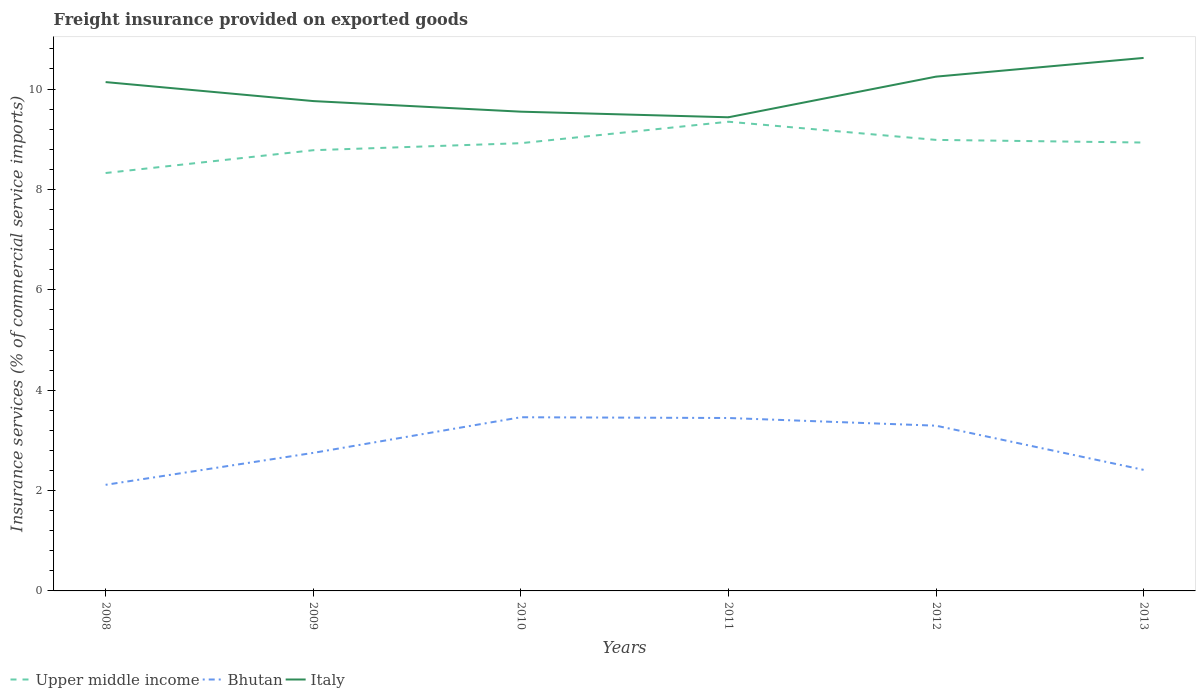How many different coloured lines are there?
Your response must be concise. 3. Is the number of lines equal to the number of legend labels?
Ensure brevity in your answer.  Yes. Across all years, what is the maximum freight insurance provided on exported goods in Italy?
Give a very brief answer. 9.44. In which year was the freight insurance provided on exported goods in Upper middle income maximum?
Give a very brief answer. 2008. What is the total freight insurance provided on exported goods in Bhutan in the graph?
Make the answer very short. 0.02. What is the difference between the highest and the second highest freight insurance provided on exported goods in Bhutan?
Keep it short and to the point. 1.35. What is the difference between the highest and the lowest freight insurance provided on exported goods in Upper middle income?
Keep it short and to the point. 4. How many lines are there?
Your answer should be compact. 3. Does the graph contain any zero values?
Your answer should be compact. No. Where does the legend appear in the graph?
Offer a terse response. Bottom left. What is the title of the graph?
Provide a succinct answer. Freight insurance provided on exported goods. What is the label or title of the Y-axis?
Offer a terse response. Insurance services (% of commercial service imports). What is the Insurance services (% of commercial service imports) in Upper middle income in 2008?
Provide a short and direct response. 8.33. What is the Insurance services (% of commercial service imports) in Bhutan in 2008?
Give a very brief answer. 2.11. What is the Insurance services (% of commercial service imports) in Italy in 2008?
Offer a terse response. 10.14. What is the Insurance services (% of commercial service imports) of Upper middle income in 2009?
Offer a very short reply. 8.78. What is the Insurance services (% of commercial service imports) of Bhutan in 2009?
Give a very brief answer. 2.75. What is the Insurance services (% of commercial service imports) of Italy in 2009?
Your answer should be compact. 9.76. What is the Insurance services (% of commercial service imports) in Upper middle income in 2010?
Offer a terse response. 8.92. What is the Insurance services (% of commercial service imports) of Bhutan in 2010?
Your response must be concise. 3.46. What is the Insurance services (% of commercial service imports) of Italy in 2010?
Your answer should be compact. 9.55. What is the Insurance services (% of commercial service imports) in Upper middle income in 2011?
Ensure brevity in your answer.  9.35. What is the Insurance services (% of commercial service imports) of Bhutan in 2011?
Your response must be concise. 3.45. What is the Insurance services (% of commercial service imports) of Italy in 2011?
Make the answer very short. 9.44. What is the Insurance services (% of commercial service imports) of Upper middle income in 2012?
Provide a short and direct response. 8.99. What is the Insurance services (% of commercial service imports) in Bhutan in 2012?
Ensure brevity in your answer.  3.29. What is the Insurance services (% of commercial service imports) of Italy in 2012?
Make the answer very short. 10.25. What is the Insurance services (% of commercial service imports) of Upper middle income in 2013?
Your answer should be very brief. 8.93. What is the Insurance services (% of commercial service imports) of Bhutan in 2013?
Your answer should be very brief. 2.41. What is the Insurance services (% of commercial service imports) of Italy in 2013?
Provide a short and direct response. 10.62. Across all years, what is the maximum Insurance services (% of commercial service imports) of Upper middle income?
Provide a short and direct response. 9.35. Across all years, what is the maximum Insurance services (% of commercial service imports) of Bhutan?
Give a very brief answer. 3.46. Across all years, what is the maximum Insurance services (% of commercial service imports) of Italy?
Provide a succinct answer. 10.62. Across all years, what is the minimum Insurance services (% of commercial service imports) in Upper middle income?
Offer a very short reply. 8.33. Across all years, what is the minimum Insurance services (% of commercial service imports) in Bhutan?
Make the answer very short. 2.11. Across all years, what is the minimum Insurance services (% of commercial service imports) of Italy?
Offer a terse response. 9.44. What is the total Insurance services (% of commercial service imports) in Upper middle income in the graph?
Ensure brevity in your answer.  53.3. What is the total Insurance services (% of commercial service imports) of Bhutan in the graph?
Keep it short and to the point. 17.47. What is the total Insurance services (% of commercial service imports) in Italy in the graph?
Your answer should be compact. 59.75. What is the difference between the Insurance services (% of commercial service imports) in Upper middle income in 2008 and that in 2009?
Give a very brief answer. -0.45. What is the difference between the Insurance services (% of commercial service imports) in Bhutan in 2008 and that in 2009?
Make the answer very short. -0.64. What is the difference between the Insurance services (% of commercial service imports) in Italy in 2008 and that in 2009?
Offer a terse response. 0.38. What is the difference between the Insurance services (% of commercial service imports) of Upper middle income in 2008 and that in 2010?
Offer a terse response. -0.59. What is the difference between the Insurance services (% of commercial service imports) of Bhutan in 2008 and that in 2010?
Give a very brief answer. -1.35. What is the difference between the Insurance services (% of commercial service imports) of Italy in 2008 and that in 2010?
Provide a succinct answer. 0.59. What is the difference between the Insurance services (% of commercial service imports) of Upper middle income in 2008 and that in 2011?
Your response must be concise. -1.02. What is the difference between the Insurance services (% of commercial service imports) of Bhutan in 2008 and that in 2011?
Your answer should be very brief. -1.33. What is the difference between the Insurance services (% of commercial service imports) of Italy in 2008 and that in 2011?
Offer a very short reply. 0.7. What is the difference between the Insurance services (% of commercial service imports) of Upper middle income in 2008 and that in 2012?
Make the answer very short. -0.66. What is the difference between the Insurance services (% of commercial service imports) of Bhutan in 2008 and that in 2012?
Your answer should be very brief. -1.18. What is the difference between the Insurance services (% of commercial service imports) of Italy in 2008 and that in 2012?
Keep it short and to the point. -0.11. What is the difference between the Insurance services (% of commercial service imports) in Upper middle income in 2008 and that in 2013?
Ensure brevity in your answer.  -0.61. What is the difference between the Insurance services (% of commercial service imports) of Bhutan in 2008 and that in 2013?
Make the answer very short. -0.3. What is the difference between the Insurance services (% of commercial service imports) in Italy in 2008 and that in 2013?
Give a very brief answer. -0.48. What is the difference between the Insurance services (% of commercial service imports) in Upper middle income in 2009 and that in 2010?
Give a very brief answer. -0.14. What is the difference between the Insurance services (% of commercial service imports) of Bhutan in 2009 and that in 2010?
Offer a terse response. -0.71. What is the difference between the Insurance services (% of commercial service imports) of Italy in 2009 and that in 2010?
Provide a succinct answer. 0.21. What is the difference between the Insurance services (% of commercial service imports) in Upper middle income in 2009 and that in 2011?
Your answer should be very brief. -0.57. What is the difference between the Insurance services (% of commercial service imports) in Bhutan in 2009 and that in 2011?
Provide a short and direct response. -0.7. What is the difference between the Insurance services (% of commercial service imports) of Italy in 2009 and that in 2011?
Provide a succinct answer. 0.32. What is the difference between the Insurance services (% of commercial service imports) in Upper middle income in 2009 and that in 2012?
Give a very brief answer. -0.21. What is the difference between the Insurance services (% of commercial service imports) of Bhutan in 2009 and that in 2012?
Give a very brief answer. -0.54. What is the difference between the Insurance services (% of commercial service imports) in Italy in 2009 and that in 2012?
Keep it short and to the point. -0.49. What is the difference between the Insurance services (% of commercial service imports) of Upper middle income in 2009 and that in 2013?
Offer a terse response. -0.15. What is the difference between the Insurance services (% of commercial service imports) in Bhutan in 2009 and that in 2013?
Your answer should be very brief. 0.34. What is the difference between the Insurance services (% of commercial service imports) in Italy in 2009 and that in 2013?
Provide a succinct answer. -0.86. What is the difference between the Insurance services (% of commercial service imports) in Upper middle income in 2010 and that in 2011?
Give a very brief answer. -0.43. What is the difference between the Insurance services (% of commercial service imports) in Bhutan in 2010 and that in 2011?
Your answer should be compact. 0.02. What is the difference between the Insurance services (% of commercial service imports) in Italy in 2010 and that in 2011?
Provide a short and direct response. 0.11. What is the difference between the Insurance services (% of commercial service imports) in Upper middle income in 2010 and that in 2012?
Ensure brevity in your answer.  -0.07. What is the difference between the Insurance services (% of commercial service imports) of Bhutan in 2010 and that in 2012?
Keep it short and to the point. 0.17. What is the difference between the Insurance services (% of commercial service imports) in Italy in 2010 and that in 2012?
Give a very brief answer. -0.7. What is the difference between the Insurance services (% of commercial service imports) of Upper middle income in 2010 and that in 2013?
Offer a very short reply. -0.01. What is the difference between the Insurance services (% of commercial service imports) in Bhutan in 2010 and that in 2013?
Offer a very short reply. 1.05. What is the difference between the Insurance services (% of commercial service imports) in Italy in 2010 and that in 2013?
Your answer should be very brief. -1.07. What is the difference between the Insurance services (% of commercial service imports) of Upper middle income in 2011 and that in 2012?
Offer a very short reply. 0.36. What is the difference between the Insurance services (% of commercial service imports) of Bhutan in 2011 and that in 2012?
Your answer should be compact. 0.15. What is the difference between the Insurance services (% of commercial service imports) of Italy in 2011 and that in 2012?
Offer a terse response. -0.81. What is the difference between the Insurance services (% of commercial service imports) in Upper middle income in 2011 and that in 2013?
Your answer should be compact. 0.41. What is the difference between the Insurance services (% of commercial service imports) in Bhutan in 2011 and that in 2013?
Your answer should be very brief. 1.03. What is the difference between the Insurance services (% of commercial service imports) in Italy in 2011 and that in 2013?
Give a very brief answer. -1.18. What is the difference between the Insurance services (% of commercial service imports) of Upper middle income in 2012 and that in 2013?
Make the answer very short. 0.05. What is the difference between the Insurance services (% of commercial service imports) of Bhutan in 2012 and that in 2013?
Your answer should be very brief. 0.88. What is the difference between the Insurance services (% of commercial service imports) of Italy in 2012 and that in 2013?
Provide a short and direct response. -0.37. What is the difference between the Insurance services (% of commercial service imports) of Upper middle income in 2008 and the Insurance services (% of commercial service imports) of Bhutan in 2009?
Provide a short and direct response. 5.58. What is the difference between the Insurance services (% of commercial service imports) of Upper middle income in 2008 and the Insurance services (% of commercial service imports) of Italy in 2009?
Give a very brief answer. -1.43. What is the difference between the Insurance services (% of commercial service imports) in Bhutan in 2008 and the Insurance services (% of commercial service imports) in Italy in 2009?
Ensure brevity in your answer.  -7.65. What is the difference between the Insurance services (% of commercial service imports) in Upper middle income in 2008 and the Insurance services (% of commercial service imports) in Bhutan in 2010?
Your answer should be very brief. 4.87. What is the difference between the Insurance services (% of commercial service imports) in Upper middle income in 2008 and the Insurance services (% of commercial service imports) in Italy in 2010?
Provide a short and direct response. -1.22. What is the difference between the Insurance services (% of commercial service imports) of Bhutan in 2008 and the Insurance services (% of commercial service imports) of Italy in 2010?
Give a very brief answer. -7.43. What is the difference between the Insurance services (% of commercial service imports) in Upper middle income in 2008 and the Insurance services (% of commercial service imports) in Bhutan in 2011?
Your response must be concise. 4.88. What is the difference between the Insurance services (% of commercial service imports) of Upper middle income in 2008 and the Insurance services (% of commercial service imports) of Italy in 2011?
Your answer should be very brief. -1.11. What is the difference between the Insurance services (% of commercial service imports) in Bhutan in 2008 and the Insurance services (% of commercial service imports) in Italy in 2011?
Make the answer very short. -7.32. What is the difference between the Insurance services (% of commercial service imports) of Upper middle income in 2008 and the Insurance services (% of commercial service imports) of Bhutan in 2012?
Keep it short and to the point. 5.03. What is the difference between the Insurance services (% of commercial service imports) of Upper middle income in 2008 and the Insurance services (% of commercial service imports) of Italy in 2012?
Your answer should be very brief. -1.92. What is the difference between the Insurance services (% of commercial service imports) of Bhutan in 2008 and the Insurance services (% of commercial service imports) of Italy in 2012?
Your response must be concise. -8.13. What is the difference between the Insurance services (% of commercial service imports) in Upper middle income in 2008 and the Insurance services (% of commercial service imports) in Bhutan in 2013?
Provide a succinct answer. 5.91. What is the difference between the Insurance services (% of commercial service imports) in Upper middle income in 2008 and the Insurance services (% of commercial service imports) in Italy in 2013?
Provide a succinct answer. -2.29. What is the difference between the Insurance services (% of commercial service imports) in Bhutan in 2008 and the Insurance services (% of commercial service imports) in Italy in 2013?
Provide a short and direct response. -8.51. What is the difference between the Insurance services (% of commercial service imports) of Upper middle income in 2009 and the Insurance services (% of commercial service imports) of Bhutan in 2010?
Offer a terse response. 5.32. What is the difference between the Insurance services (% of commercial service imports) of Upper middle income in 2009 and the Insurance services (% of commercial service imports) of Italy in 2010?
Your answer should be very brief. -0.77. What is the difference between the Insurance services (% of commercial service imports) of Bhutan in 2009 and the Insurance services (% of commercial service imports) of Italy in 2010?
Provide a short and direct response. -6.8. What is the difference between the Insurance services (% of commercial service imports) in Upper middle income in 2009 and the Insurance services (% of commercial service imports) in Bhutan in 2011?
Give a very brief answer. 5.34. What is the difference between the Insurance services (% of commercial service imports) of Upper middle income in 2009 and the Insurance services (% of commercial service imports) of Italy in 2011?
Your answer should be very brief. -0.66. What is the difference between the Insurance services (% of commercial service imports) in Bhutan in 2009 and the Insurance services (% of commercial service imports) in Italy in 2011?
Your answer should be very brief. -6.69. What is the difference between the Insurance services (% of commercial service imports) of Upper middle income in 2009 and the Insurance services (% of commercial service imports) of Bhutan in 2012?
Ensure brevity in your answer.  5.49. What is the difference between the Insurance services (% of commercial service imports) in Upper middle income in 2009 and the Insurance services (% of commercial service imports) in Italy in 2012?
Provide a succinct answer. -1.47. What is the difference between the Insurance services (% of commercial service imports) of Bhutan in 2009 and the Insurance services (% of commercial service imports) of Italy in 2012?
Give a very brief answer. -7.5. What is the difference between the Insurance services (% of commercial service imports) of Upper middle income in 2009 and the Insurance services (% of commercial service imports) of Bhutan in 2013?
Your answer should be compact. 6.37. What is the difference between the Insurance services (% of commercial service imports) in Upper middle income in 2009 and the Insurance services (% of commercial service imports) in Italy in 2013?
Give a very brief answer. -1.84. What is the difference between the Insurance services (% of commercial service imports) in Bhutan in 2009 and the Insurance services (% of commercial service imports) in Italy in 2013?
Ensure brevity in your answer.  -7.87. What is the difference between the Insurance services (% of commercial service imports) of Upper middle income in 2010 and the Insurance services (% of commercial service imports) of Bhutan in 2011?
Make the answer very short. 5.48. What is the difference between the Insurance services (% of commercial service imports) in Upper middle income in 2010 and the Insurance services (% of commercial service imports) in Italy in 2011?
Your answer should be compact. -0.52. What is the difference between the Insurance services (% of commercial service imports) in Bhutan in 2010 and the Insurance services (% of commercial service imports) in Italy in 2011?
Your response must be concise. -5.98. What is the difference between the Insurance services (% of commercial service imports) of Upper middle income in 2010 and the Insurance services (% of commercial service imports) of Bhutan in 2012?
Offer a very short reply. 5.63. What is the difference between the Insurance services (% of commercial service imports) of Upper middle income in 2010 and the Insurance services (% of commercial service imports) of Italy in 2012?
Ensure brevity in your answer.  -1.33. What is the difference between the Insurance services (% of commercial service imports) in Bhutan in 2010 and the Insurance services (% of commercial service imports) in Italy in 2012?
Ensure brevity in your answer.  -6.79. What is the difference between the Insurance services (% of commercial service imports) of Upper middle income in 2010 and the Insurance services (% of commercial service imports) of Bhutan in 2013?
Offer a terse response. 6.51. What is the difference between the Insurance services (% of commercial service imports) of Upper middle income in 2010 and the Insurance services (% of commercial service imports) of Italy in 2013?
Offer a terse response. -1.7. What is the difference between the Insurance services (% of commercial service imports) in Bhutan in 2010 and the Insurance services (% of commercial service imports) in Italy in 2013?
Offer a terse response. -7.16. What is the difference between the Insurance services (% of commercial service imports) of Upper middle income in 2011 and the Insurance services (% of commercial service imports) of Bhutan in 2012?
Ensure brevity in your answer.  6.06. What is the difference between the Insurance services (% of commercial service imports) of Upper middle income in 2011 and the Insurance services (% of commercial service imports) of Italy in 2012?
Make the answer very short. -0.9. What is the difference between the Insurance services (% of commercial service imports) in Bhutan in 2011 and the Insurance services (% of commercial service imports) in Italy in 2012?
Keep it short and to the point. -6.8. What is the difference between the Insurance services (% of commercial service imports) of Upper middle income in 2011 and the Insurance services (% of commercial service imports) of Bhutan in 2013?
Provide a succinct answer. 6.94. What is the difference between the Insurance services (% of commercial service imports) of Upper middle income in 2011 and the Insurance services (% of commercial service imports) of Italy in 2013?
Offer a very short reply. -1.27. What is the difference between the Insurance services (% of commercial service imports) in Bhutan in 2011 and the Insurance services (% of commercial service imports) in Italy in 2013?
Your answer should be compact. -7.17. What is the difference between the Insurance services (% of commercial service imports) in Upper middle income in 2012 and the Insurance services (% of commercial service imports) in Bhutan in 2013?
Ensure brevity in your answer.  6.57. What is the difference between the Insurance services (% of commercial service imports) in Upper middle income in 2012 and the Insurance services (% of commercial service imports) in Italy in 2013?
Provide a short and direct response. -1.63. What is the difference between the Insurance services (% of commercial service imports) in Bhutan in 2012 and the Insurance services (% of commercial service imports) in Italy in 2013?
Give a very brief answer. -7.33. What is the average Insurance services (% of commercial service imports) in Upper middle income per year?
Your response must be concise. 8.88. What is the average Insurance services (% of commercial service imports) of Bhutan per year?
Your response must be concise. 2.91. What is the average Insurance services (% of commercial service imports) of Italy per year?
Keep it short and to the point. 9.96. In the year 2008, what is the difference between the Insurance services (% of commercial service imports) in Upper middle income and Insurance services (% of commercial service imports) in Bhutan?
Your answer should be compact. 6.21. In the year 2008, what is the difference between the Insurance services (% of commercial service imports) of Upper middle income and Insurance services (% of commercial service imports) of Italy?
Keep it short and to the point. -1.81. In the year 2008, what is the difference between the Insurance services (% of commercial service imports) of Bhutan and Insurance services (% of commercial service imports) of Italy?
Your answer should be very brief. -8.02. In the year 2009, what is the difference between the Insurance services (% of commercial service imports) in Upper middle income and Insurance services (% of commercial service imports) in Bhutan?
Your response must be concise. 6.03. In the year 2009, what is the difference between the Insurance services (% of commercial service imports) in Upper middle income and Insurance services (% of commercial service imports) in Italy?
Ensure brevity in your answer.  -0.98. In the year 2009, what is the difference between the Insurance services (% of commercial service imports) in Bhutan and Insurance services (% of commercial service imports) in Italy?
Your answer should be compact. -7.01. In the year 2010, what is the difference between the Insurance services (% of commercial service imports) of Upper middle income and Insurance services (% of commercial service imports) of Bhutan?
Your answer should be compact. 5.46. In the year 2010, what is the difference between the Insurance services (% of commercial service imports) in Upper middle income and Insurance services (% of commercial service imports) in Italy?
Give a very brief answer. -0.63. In the year 2010, what is the difference between the Insurance services (% of commercial service imports) in Bhutan and Insurance services (% of commercial service imports) in Italy?
Your response must be concise. -6.09. In the year 2011, what is the difference between the Insurance services (% of commercial service imports) of Upper middle income and Insurance services (% of commercial service imports) of Bhutan?
Your response must be concise. 5.9. In the year 2011, what is the difference between the Insurance services (% of commercial service imports) of Upper middle income and Insurance services (% of commercial service imports) of Italy?
Your answer should be very brief. -0.09. In the year 2011, what is the difference between the Insurance services (% of commercial service imports) in Bhutan and Insurance services (% of commercial service imports) in Italy?
Give a very brief answer. -5.99. In the year 2012, what is the difference between the Insurance services (% of commercial service imports) in Upper middle income and Insurance services (% of commercial service imports) in Bhutan?
Your answer should be very brief. 5.69. In the year 2012, what is the difference between the Insurance services (% of commercial service imports) of Upper middle income and Insurance services (% of commercial service imports) of Italy?
Your response must be concise. -1.26. In the year 2012, what is the difference between the Insurance services (% of commercial service imports) of Bhutan and Insurance services (% of commercial service imports) of Italy?
Ensure brevity in your answer.  -6.95. In the year 2013, what is the difference between the Insurance services (% of commercial service imports) of Upper middle income and Insurance services (% of commercial service imports) of Bhutan?
Your response must be concise. 6.52. In the year 2013, what is the difference between the Insurance services (% of commercial service imports) in Upper middle income and Insurance services (% of commercial service imports) in Italy?
Offer a terse response. -1.69. In the year 2013, what is the difference between the Insurance services (% of commercial service imports) of Bhutan and Insurance services (% of commercial service imports) of Italy?
Give a very brief answer. -8.21. What is the ratio of the Insurance services (% of commercial service imports) of Upper middle income in 2008 to that in 2009?
Make the answer very short. 0.95. What is the ratio of the Insurance services (% of commercial service imports) in Bhutan in 2008 to that in 2009?
Your answer should be very brief. 0.77. What is the ratio of the Insurance services (% of commercial service imports) in Italy in 2008 to that in 2009?
Provide a succinct answer. 1.04. What is the ratio of the Insurance services (% of commercial service imports) of Upper middle income in 2008 to that in 2010?
Your response must be concise. 0.93. What is the ratio of the Insurance services (% of commercial service imports) of Bhutan in 2008 to that in 2010?
Offer a very short reply. 0.61. What is the ratio of the Insurance services (% of commercial service imports) in Italy in 2008 to that in 2010?
Ensure brevity in your answer.  1.06. What is the ratio of the Insurance services (% of commercial service imports) of Upper middle income in 2008 to that in 2011?
Provide a short and direct response. 0.89. What is the ratio of the Insurance services (% of commercial service imports) of Bhutan in 2008 to that in 2011?
Provide a succinct answer. 0.61. What is the ratio of the Insurance services (% of commercial service imports) of Italy in 2008 to that in 2011?
Give a very brief answer. 1.07. What is the ratio of the Insurance services (% of commercial service imports) of Upper middle income in 2008 to that in 2012?
Provide a succinct answer. 0.93. What is the ratio of the Insurance services (% of commercial service imports) of Bhutan in 2008 to that in 2012?
Your answer should be very brief. 0.64. What is the ratio of the Insurance services (% of commercial service imports) in Italy in 2008 to that in 2012?
Keep it short and to the point. 0.99. What is the ratio of the Insurance services (% of commercial service imports) in Upper middle income in 2008 to that in 2013?
Keep it short and to the point. 0.93. What is the ratio of the Insurance services (% of commercial service imports) of Bhutan in 2008 to that in 2013?
Your response must be concise. 0.88. What is the ratio of the Insurance services (% of commercial service imports) of Italy in 2008 to that in 2013?
Offer a very short reply. 0.95. What is the ratio of the Insurance services (% of commercial service imports) in Upper middle income in 2009 to that in 2010?
Provide a succinct answer. 0.98. What is the ratio of the Insurance services (% of commercial service imports) in Bhutan in 2009 to that in 2010?
Keep it short and to the point. 0.79. What is the ratio of the Insurance services (% of commercial service imports) in Italy in 2009 to that in 2010?
Give a very brief answer. 1.02. What is the ratio of the Insurance services (% of commercial service imports) of Upper middle income in 2009 to that in 2011?
Offer a terse response. 0.94. What is the ratio of the Insurance services (% of commercial service imports) of Bhutan in 2009 to that in 2011?
Your answer should be compact. 0.8. What is the ratio of the Insurance services (% of commercial service imports) in Italy in 2009 to that in 2011?
Provide a succinct answer. 1.03. What is the ratio of the Insurance services (% of commercial service imports) of Upper middle income in 2009 to that in 2012?
Provide a short and direct response. 0.98. What is the ratio of the Insurance services (% of commercial service imports) in Bhutan in 2009 to that in 2012?
Keep it short and to the point. 0.84. What is the ratio of the Insurance services (% of commercial service imports) of Italy in 2009 to that in 2012?
Offer a terse response. 0.95. What is the ratio of the Insurance services (% of commercial service imports) in Upper middle income in 2009 to that in 2013?
Offer a terse response. 0.98. What is the ratio of the Insurance services (% of commercial service imports) in Bhutan in 2009 to that in 2013?
Ensure brevity in your answer.  1.14. What is the ratio of the Insurance services (% of commercial service imports) of Italy in 2009 to that in 2013?
Offer a very short reply. 0.92. What is the ratio of the Insurance services (% of commercial service imports) of Upper middle income in 2010 to that in 2011?
Offer a terse response. 0.95. What is the ratio of the Insurance services (% of commercial service imports) of Bhutan in 2010 to that in 2011?
Your answer should be very brief. 1. What is the ratio of the Insurance services (% of commercial service imports) in Italy in 2010 to that in 2011?
Keep it short and to the point. 1.01. What is the ratio of the Insurance services (% of commercial service imports) in Upper middle income in 2010 to that in 2012?
Give a very brief answer. 0.99. What is the ratio of the Insurance services (% of commercial service imports) in Bhutan in 2010 to that in 2012?
Keep it short and to the point. 1.05. What is the ratio of the Insurance services (% of commercial service imports) in Italy in 2010 to that in 2012?
Provide a succinct answer. 0.93. What is the ratio of the Insurance services (% of commercial service imports) in Upper middle income in 2010 to that in 2013?
Offer a very short reply. 1. What is the ratio of the Insurance services (% of commercial service imports) in Bhutan in 2010 to that in 2013?
Give a very brief answer. 1.43. What is the ratio of the Insurance services (% of commercial service imports) in Italy in 2010 to that in 2013?
Provide a succinct answer. 0.9. What is the ratio of the Insurance services (% of commercial service imports) in Upper middle income in 2011 to that in 2012?
Give a very brief answer. 1.04. What is the ratio of the Insurance services (% of commercial service imports) in Bhutan in 2011 to that in 2012?
Your answer should be compact. 1.05. What is the ratio of the Insurance services (% of commercial service imports) of Italy in 2011 to that in 2012?
Keep it short and to the point. 0.92. What is the ratio of the Insurance services (% of commercial service imports) in Upper middle income in 2011 to that in 2013?
Keep it short and to the point. 1.05. What is the ratio of the Insurance services (% of commercial service imports) of Bhutan in 2011 to that in 2013?
Offer a terse response. 1.43. What is the ratio of the Insurance services (% of commercial service imports) in Italy in 2011 to that in 2013?
Provide a succinct answer. 0.89. What is the ratio of the Insurance services (% of commercial service imports) of Upper middle income in 2012 to that in 2013?
Your response must be concise. 1.01. What is the ratio of the Insurance services (% of commercial service imports) in Bhutan in 2012 to that in 2013?
Your response must be concise. 1.36. What is the ratio of the Insurance services (% of commercial service imports) of Italy in 2012 to that in 2013?
Ensure brevity in your answer.  0.96. What is the difference between the highest and the second highest Insurance services (% of commercial service imports) in Upper middle income?
Make the answer very short. 0.36. What is the difference between the highest and the second highest Insurance services (% of commercial service imports) in Bhutan?
Your response must be concise. 0.02. What is the difference between the highest and the second highest Insurance services (% of commercial service imports) in Italy?
Provide a succinct answer. 0.37. What is the difference between the highest and the lowest Insurance services (% of commercial service imports) in Upper middle income?
Keep it short and to the point. 1.02. What is the difference between the highest and the lowest Insurance services (% of commercial service imports) in Bhutan?
Your response must be concise. 1.35. What is the difference between the highest and the lowest Insurance services (% of commercial service imports) of Italy?
Make the answer very short. 1.18. 